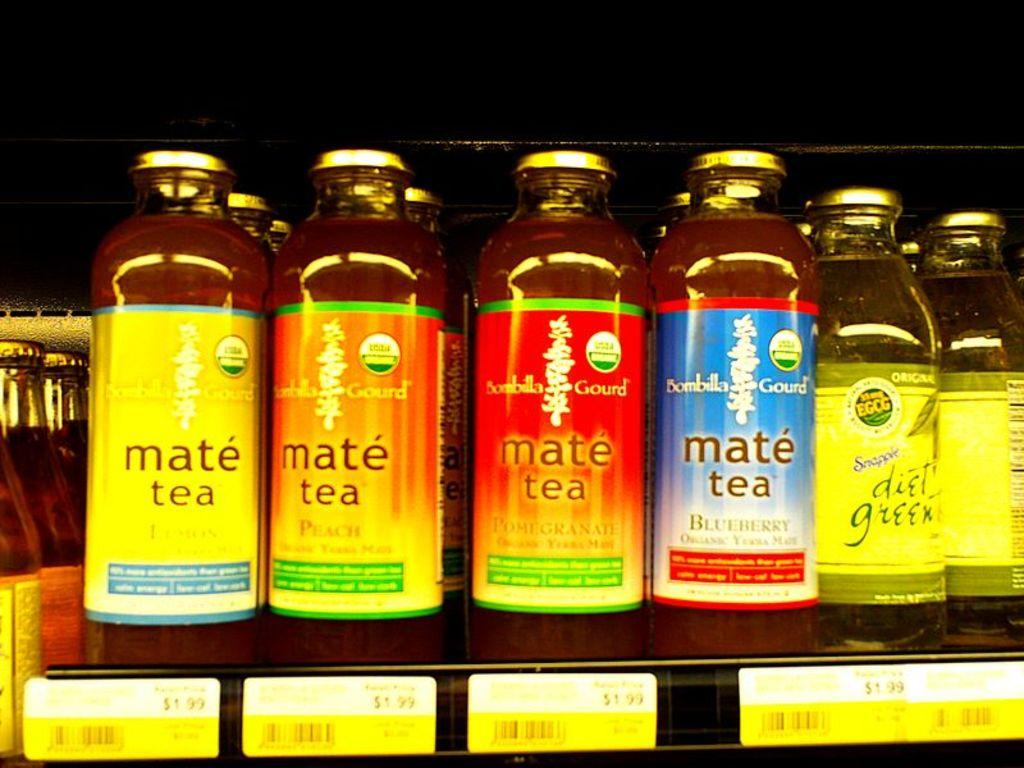Provide a one-sentence caption for the provided image. A few bottles of Mate Tea on a store shelf. 